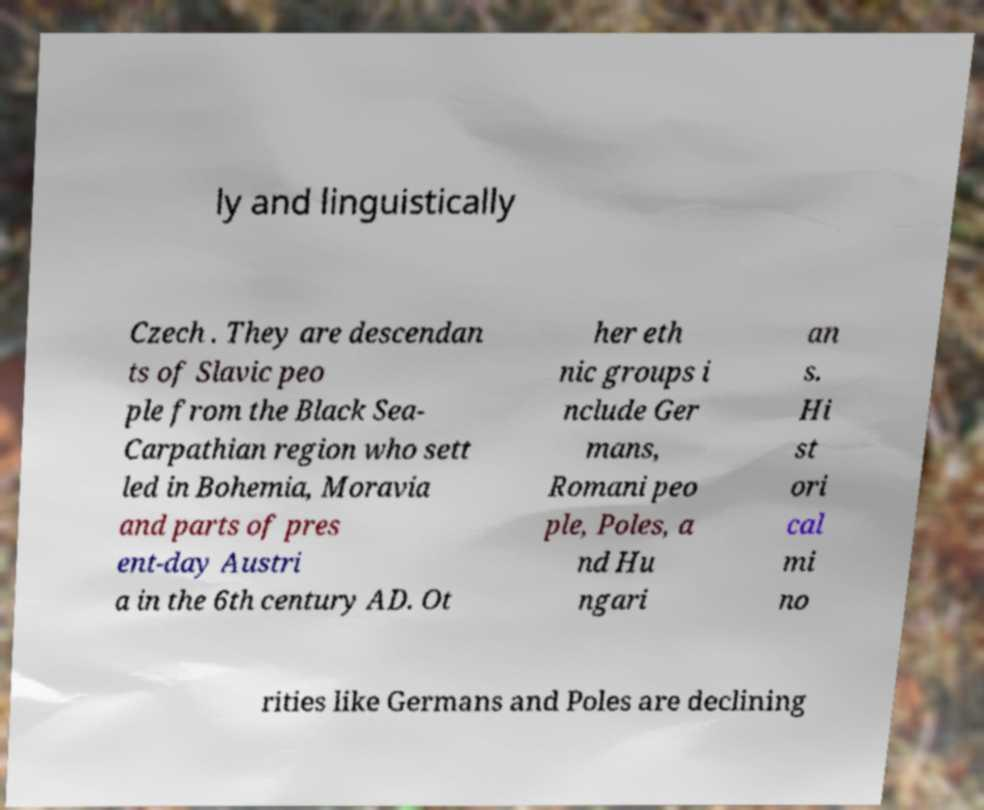I need the written content from this picture converted into text. Can you do that? ly and linguistically Czech . They are descendan ts of Slavic peo ple from the Black Sea- Carpathian region who sett led in Bohemia, Moravia and parts of pres ent-day Austri a in the 6th century AD. Ot her eth nic groups i nclude Ger mans, Romani peo ple, Poles, a nd Hu ngari an s. Hi st ori cal mi no rities like Germans and Poles are declining 